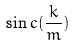Convert formula to latex. <formula><loc_0><loc_0><loc_500><loc_500>\sin c ( \frac { k } { m } )</formula> 